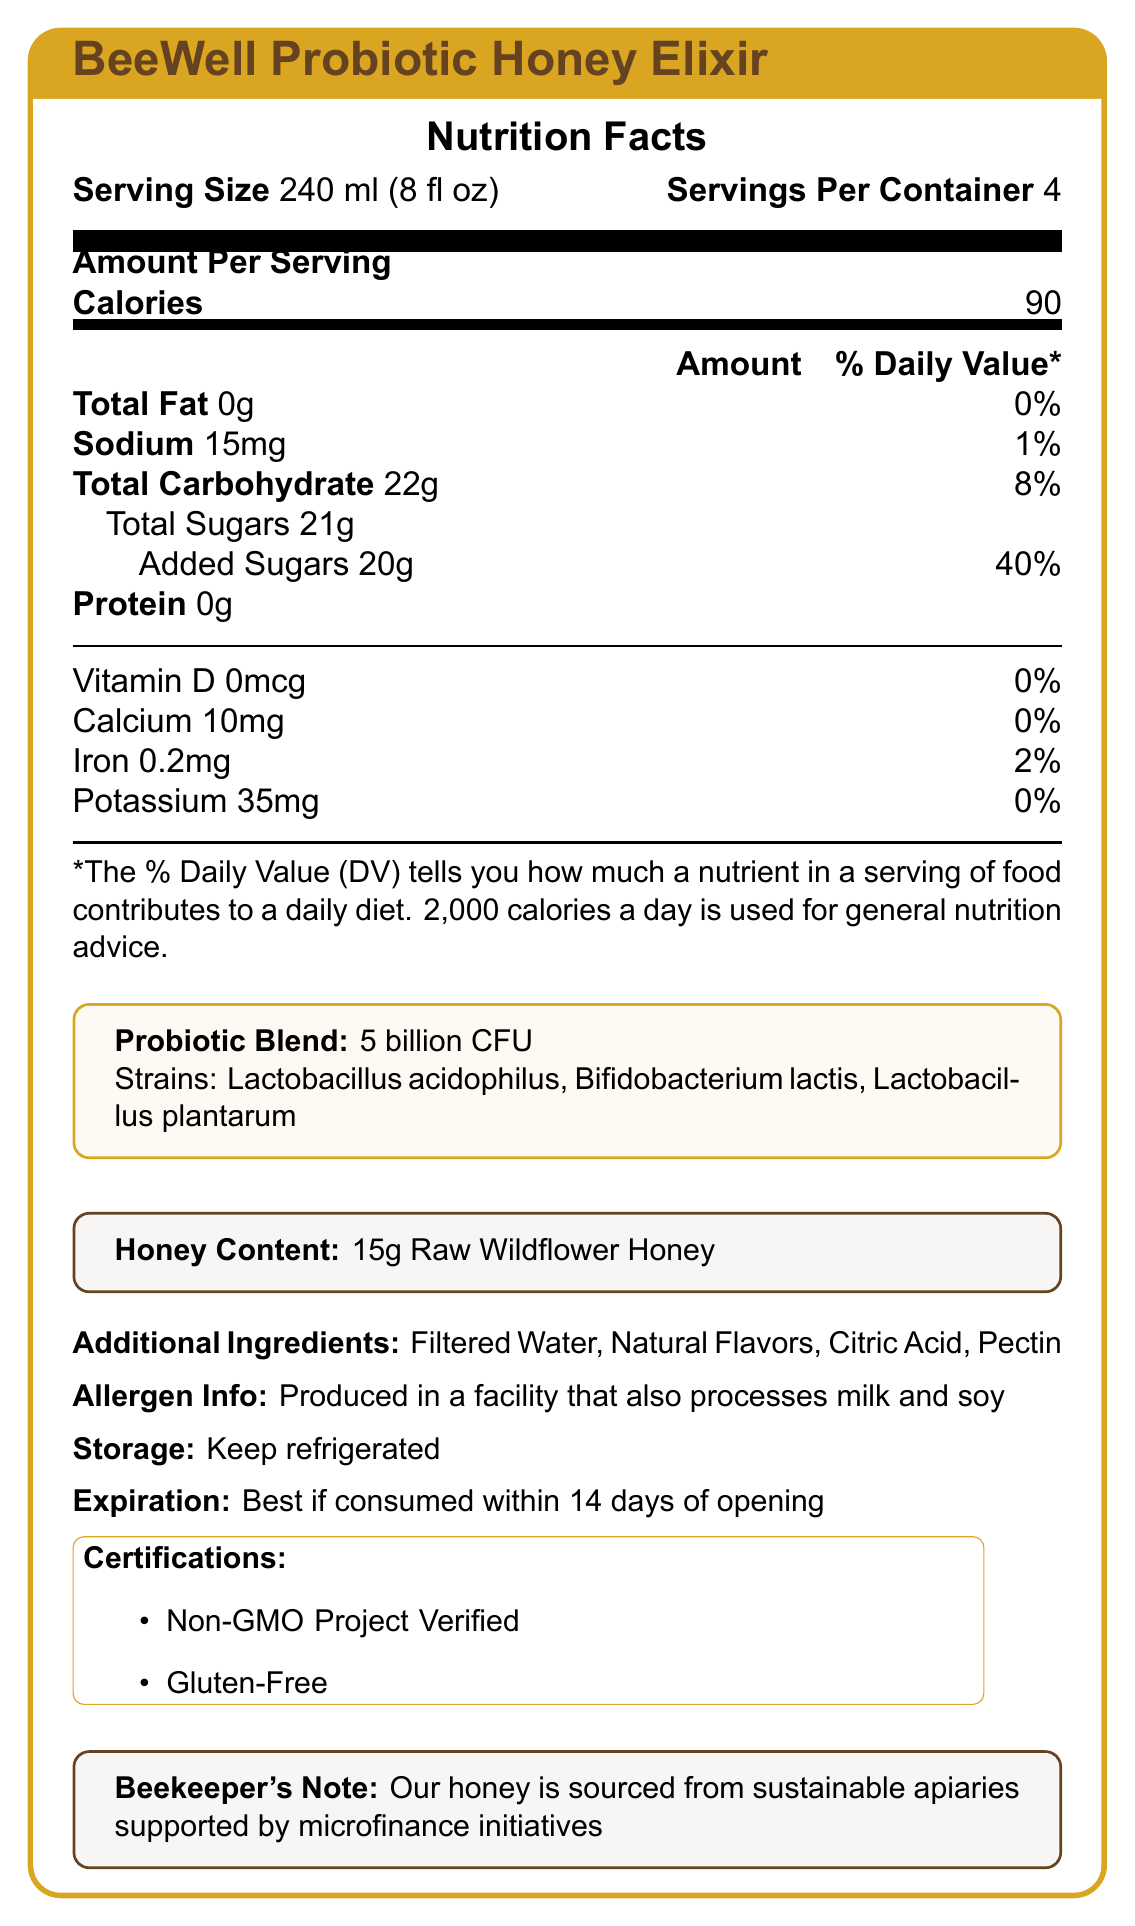what is the serving size for BeeWell Probiotic Honey Elixir? The serving size for BeeWell Probiotic Honey Elixir is clearly mentioned as 240 ml (8 fl oz) in the document.
Answer: 240 ml (8 fl oz) how many servings are there in one container? The document states that there are 4 servings per container.
Answer: 4 how many calories are in one serving? The nutrition facts indicate that each serving contains 90 calories.
Answer: 90 what percentage of the daily value is contributed by the added sugars? The amount of added sugars is 20g, which constitutes 40% of the daily value.
Answer: 40% which probiotic strains are included in the drink? The probiotics blend includes Lactobacillus acidophilus, Bifidobacterium lactis, and Lactobacillus plantarum.
Answer: Lactobacillus acidophilus, Bifidobacterium lactis, Lactobacillus plantarum what type of honey is used in the BeeWell Probiotic Honey Elixir? A. Manuka Honey B. Raw Wildflower Honey C. Clover Honey D. Buckwheat Honey The document specifies that the honey content is 15g of Raw Wildflower Honey.
Answer: B. Raw Wildflower Honey what is the amount of sodium per serving? A. 0 mg B. 10 mg C. 15 mg D. 35 mg The document indicates that one serving contains 15mg of sodium.
Answer: C. 15 mg are there any allergen warnings for this product? The document states that the product is produced in a facility that also processes milk and soy.
Answer: Yes is the BeeWell Probiotic Honey Elixir certified gluten-free? One of the certifications listed is "Gluten-Free."
Answer: Yes is there any protein in the drink? The document mentions that the protein content is 0g per serving.
Answer: No summarize the main details of the BeeWell Probiotic Honey Elixir. The BeeWell Probiotic Honey Elixir combines raw wildflower honey and probiotics in a nutritious, gluten-free drink that delivers 90 calories per serving along with other nutritional information for a comprehensive overview of the product.
Answer: The BeeWell Probiotic Honey Elixir is a honey-infused probiotic drink with 90 calories per 240 ml serving. It includes 5 billion CFU of beneficial bacteria from Lactobacillus acidophilus, Bifidobacterium lactis, and Lactobacillus plantarum strains. It contains 15g of raw wildflower honey and has additional ingredients such as filtered water, natural flavors, citric acid, and pectin. The drink is non-GMO, gluten-free, and produced in a facility that also processes milk and soy. It is best consumed within 14 days of opening and should be kept refrigerated. how many grams of total carbohydrates are in one serving? The total carbohydrate content per serving is documented as 22g.
Answer: 22g how should the BeeWell Probiotic Honey Elixir be stored? The document specifies that the product should be kept refrigerated.
Answer: Keep refrigerated from where is the honey sourced for this drink? The beekeeper's note mentions that the honey is sourced from sustainable apiaries supported by microfinance initiatives.
Answer: Sustainable apiaries supported by microfinance initiatives what is the expiration guideline once the container is opened? According to the document, the drink is best if consumed within 14 days of opening.
Answer: Best if consumed within 14 days of opening what is the calcium daily value percentage per serving? The document shows that the daily value percentage for calcium is 0% per serving.
Answer: 0% what additional ingredients are in the elixir? A. Citric Acid B. Pectin C. Natural Flavors D. All of the above The additional ingredients listed are Citric Acid, Pectin, and Natural Flavors, along with Filtered Water.
Answer: D. All of the above what is the daily iron value percentage per serving? The iron daily value percentage per serving is 2% as indicated in the document.
Answer: 2% what is the total amount of raw wildflower honey in one container? Each serving contains 15g of raw wildflower honey, and with 4 servings per container, this totals 60g.
Answer: 60g what is the drink named? The product name specified in the document is BeeWell Probiotic Honey Elixir.
Answer: BeeWell Probiotic Honey Elixir how many calories should someone consume per day, generally recommended as in the document? The document specifies that 2,000 calories a day is used for general nutrition advice.
Answer: 2,000 calories what is the percentage of the daily value for Vitamin D per serving? The Vitamin D daily value per serving is 0% according to the document.
Answer: 0% what kind of bacteria are included in the probiotic blend of the elixir? The document does not specify this information; it only lists the strains without context on their nature.
Answer: Cannot be determined 